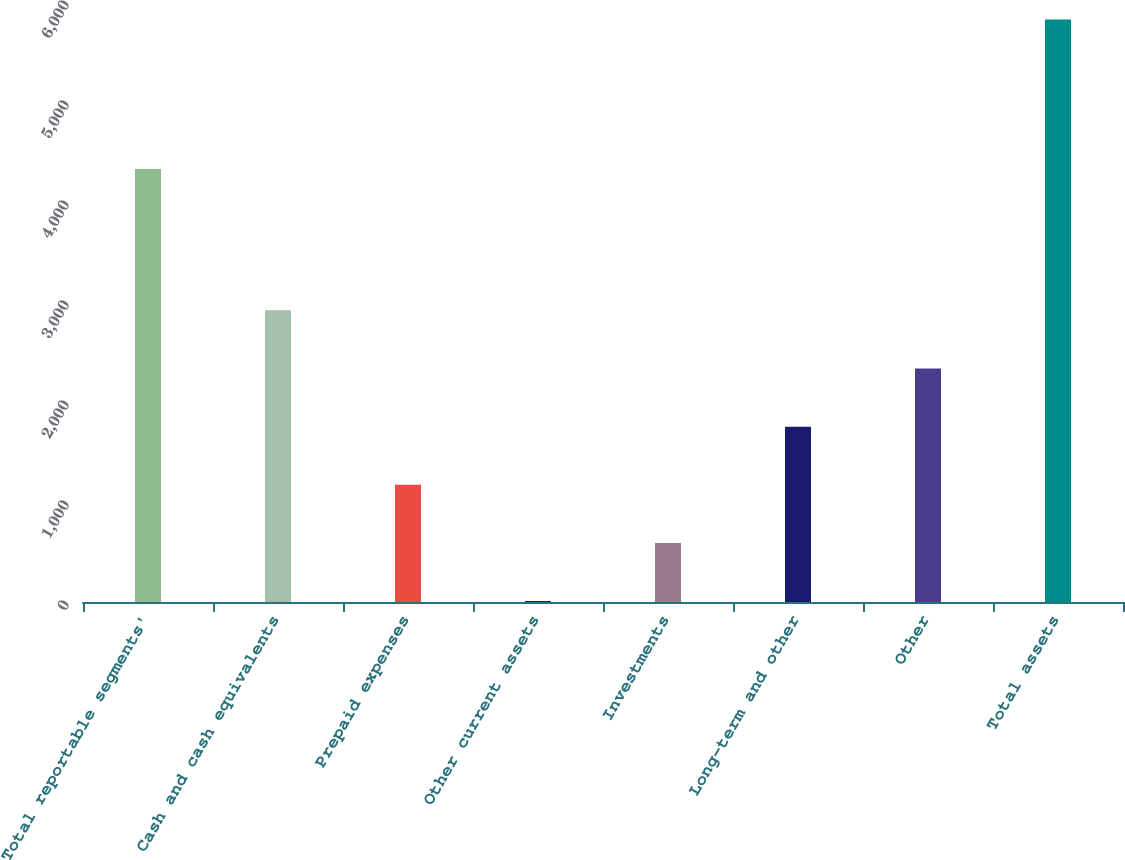Convert chart. <chart><loc_0><loc_0><loc_500><loc_500><bar_chart><fcel>Total reportable segments'<fcel>Cash and cash equivalents<fcel>Prepaid expenses<fcel>Other current assets<fcel>Investments<fcel>Long-term and other<fcel>Other<fcel>Total assets<nl><fcel>4330<fcel>2916.5<fcel>1172<fcel>9<fcel>590.5<fcel>1753.5<fcel>2335<fcel>5824<nl></chart> 